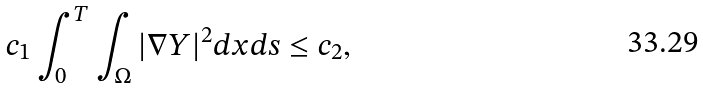<formula> <loc_0><loc_0><loc_500><loc_500>c _ { 1 } \int _ { 0 } ^ { T } \int _ { \Omega } | \nabla Y | ^ { 2 } d x d s \leq c _ { 2 } ,</formula> 